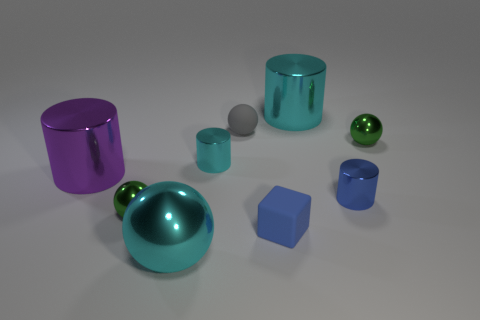Subtract all gray rubber spheres. How many spheres are left? 3 Subtract all cyan spheres. How many spheres are left? 3 Subtract all blocks. How many objects are left? 8 Subtract 1 cubes. How many cubes are left? 0 Subtract all gray spheres. Subtract all green cylinders. How many spheres are left? 3 Subtract all brown cylinders. How many green balls are left? 2 Subtract all cyan metal cylinders. Subtract all tiny shiny cylinders. How many objects are left? 5 Add 3 green balls. How many green balls are left? 5 Add 5 cyan metal cylinders. How many cyan metal cylinders exist? 7 Add 1 purple metallic cylinders. How many objects exist? 10 